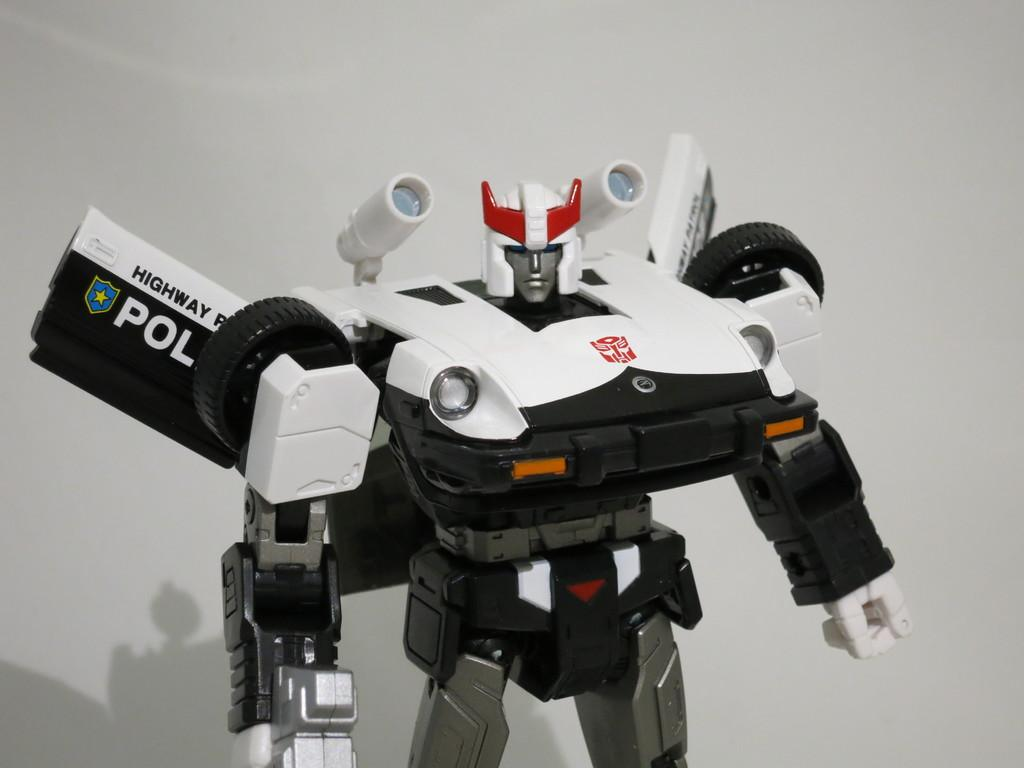What type of toy is in the image? There is a transformer-like toy in the image. What color is the toy? The toy is white in color. What type of carriage is present in the image? There is no carriage present in the image; it features a transformer-like toy. How does the toy's behavior change in the image? The toy's behavior cannot be determined from the image, as it is a static representation. 